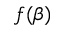Convert formula to latex. <formula><loc_0><loc_0><loc_500><loc_500>f ( \beta )</formula> 